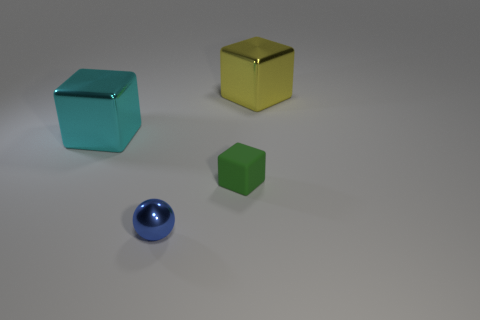Is there anything else that has the same material as the green cube?
Your response must be concise. No. There is a block that is behind the large thing that is in front of the large metal block that is on the right side of the green matte block; what is its material?
Provide a short and direct response. Metal. Does the blue thing have the same material as the green block?
Provide a succinct answer. No. There is a object that is in front of the large cyan metallic thing and to the left of the green matte object; what is its material?
Make the answer very short. Metal. How many big yellow metal things have the same shape as the big cyan object?
Offer a terse response. 1. What number of blocks are both on the right side of the big cyan thing and left of the small green object?
Offer a terse response. 0. What is the color of the shiny sphere?
Your answer should be compact. Blue. Is there another tiny blue sphere made of the same material as the blue sphere?
Give a very brief answer. No. Are there any small blocks that are in front of the small rubber cube in front of the thing behind the cyan object?
Offer a very short reply. No. Are there any green objects right of the small green matte thing?
Provide a succinct answer. No. 